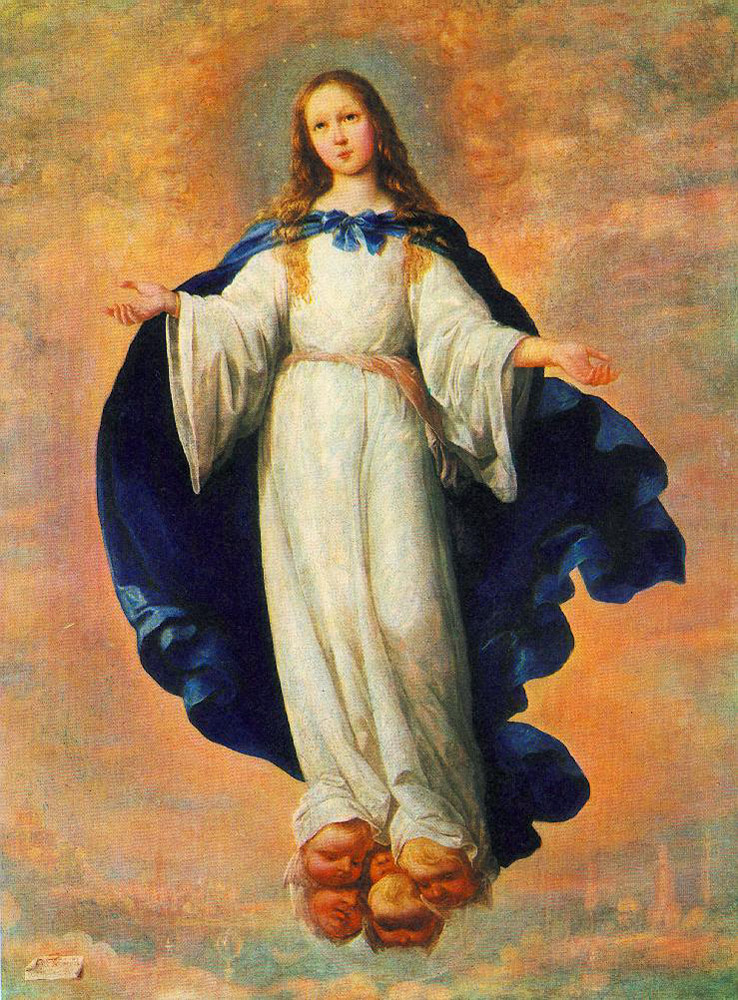How does the use of color contribute to the mood of the painting? The use of soft, warm colors in the sky and the girl's gentle, pale attire creates a calm and serene atmosphere. The contrast between her striking blue cloak and the muted background emphasizes her significance in the painting, possibly highlighting her as a central figure of spiritual importance. The overall color palette evokes a sense of tranquility and the sacred. 